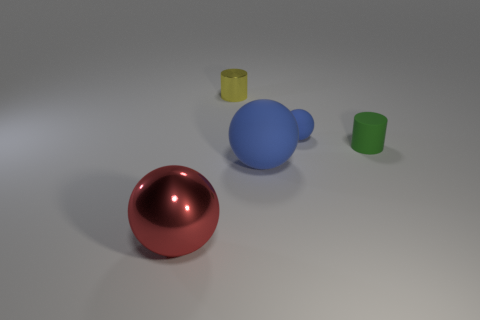What is the shape of the matte thing that is the same size as the matte cylinder?
Keep it short and to the point. Sphere. There is a big thing that is to the left of the big blue rubber ball; does it have the same color as the metal cylinder?
Ensure brevity in your answer.  No. How many objects are matte objects that are in front of the tiny blue matte object or red metal things?
Provide a short and direct response. 3. Is the number of large red shiny objects that are in front of the big red shiny sphere greater than the number of small yellow shiny cylinders left of the small yellow metal thing?
Your answer should be compact. No. Are the small blue ball and the yellow cylinder made of the same material?
Make the answer very short. No. There is a object that is on the right side of the small shiny cylinder and in front of the green thing; what shape is it?
Your answer should be compact. Sphere. What is the shape of the tiny green thing that is made of the same material as the small blue thing?
Provide a short and direct response. Cylinder. Is there a small cyan matte sphere?
Keep it short and to the point. No. Is there a yellow metallic cylinder that is on the left side of the big object left of the big matte thing?
Offer a terse response. No. There is a tiny green thing that is the same shape as the tiny yellow shiny thing; what material is it?
Your answer should be compact. Rubber. 